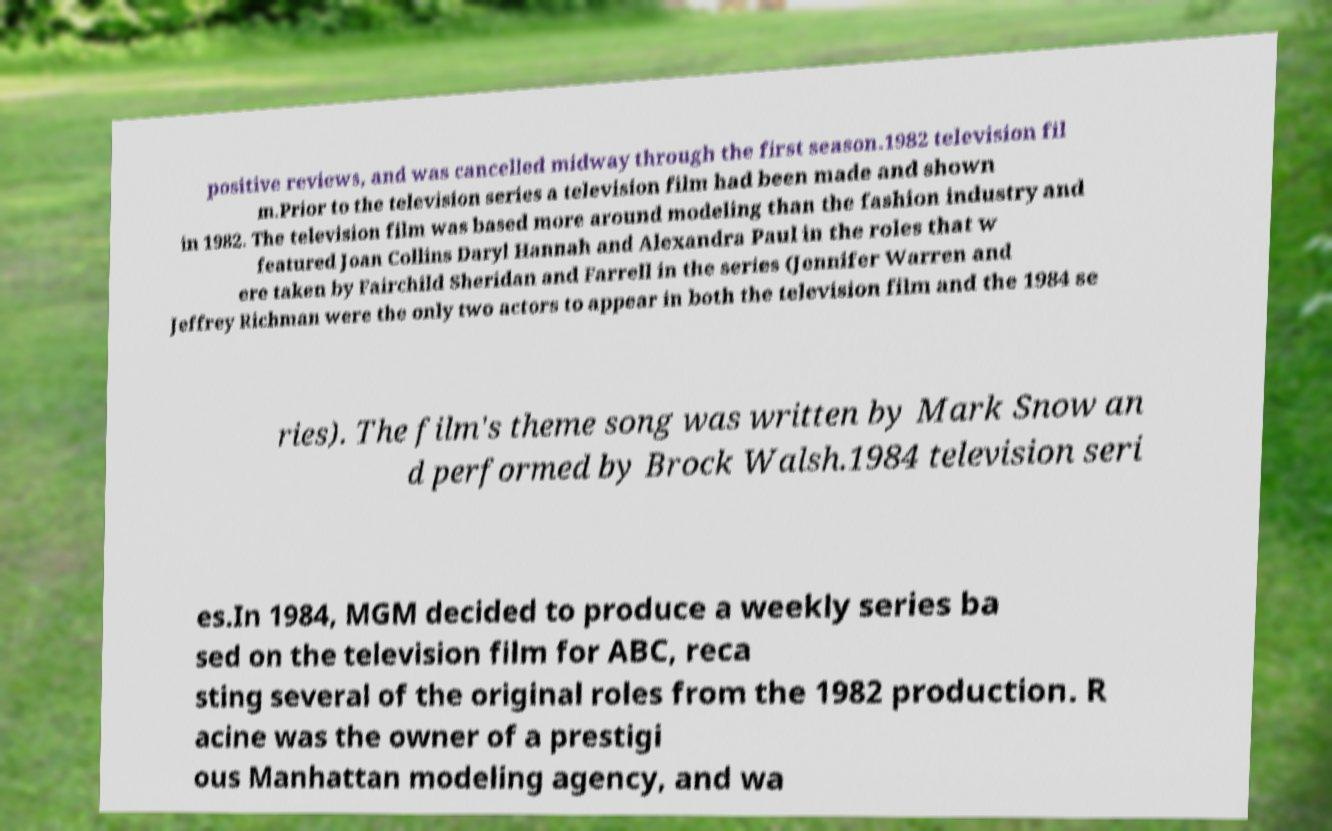Please read and relay the text visible in this image. What does it say? positive reviews, and was cancelled midway through the first season.1982 television fil m.Prior to the television series a television film had been made and shown in 1982. The television film was based more around modeling than the fashion industry and featured Joan Collins Daryl Hannah and Alexandra Paul in the roles that w ere taken by Fairchild Sheridan and Farrell in the series (Jennifer Warren and Jeffrey Richman were the only two actors to appear in both the television film and the 1984 se ries). The film's theme song was written by Mark Snow an d performed by Brock Walsh.1984 television seri es.In 1984, MGM decided to produce a weekly series ba sed on the television film for ABC, reca sting several of the original roles from the 1982 production. R acine was the owner of a prestigi ous Manhattan modeling agency, and wa 